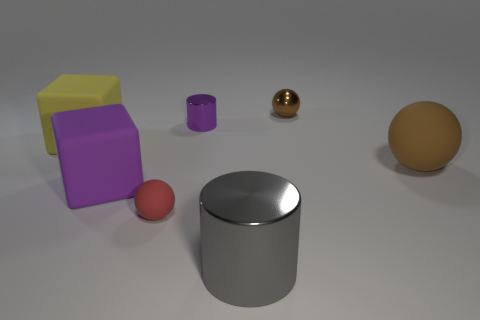What is the size of the metallic object that is in front of the tiny brown metal thing and to the right of the tiny metal cylinder?
Make the answer very short. Large. Is there any other thing that has the same color as the tiny matte object?
Provide a short and direct response. No. What is the size of the brown ball that is in front of the metallic thing behind the small cylinder?
Offer a very short reply. Large. The thing that is both behind the yellow rubber cube and on the right side of the big metallic cylinder is what color?
Keep it short and to the point. Brown. How many other objects are the same size as the brown metallic object?
Make the answer very short. 2. Is the size of the gray thing the same as the purple block that is left of the brown metallic object?
Give a very brief answer. Yes. What is the color of the cylinder that is the same size as the yellow block?
Your response must be concise. Gray. The gray thing has what size?
Provide a short and direct response. Large. Is the material of the ball that is on the left side of the big gray metallic cylinder the same as the purple block?
Make the answer very short. Yes. Do the small purple thing and the big gray metallic object have the same shape?
Your answer should be very brief. Yes. 